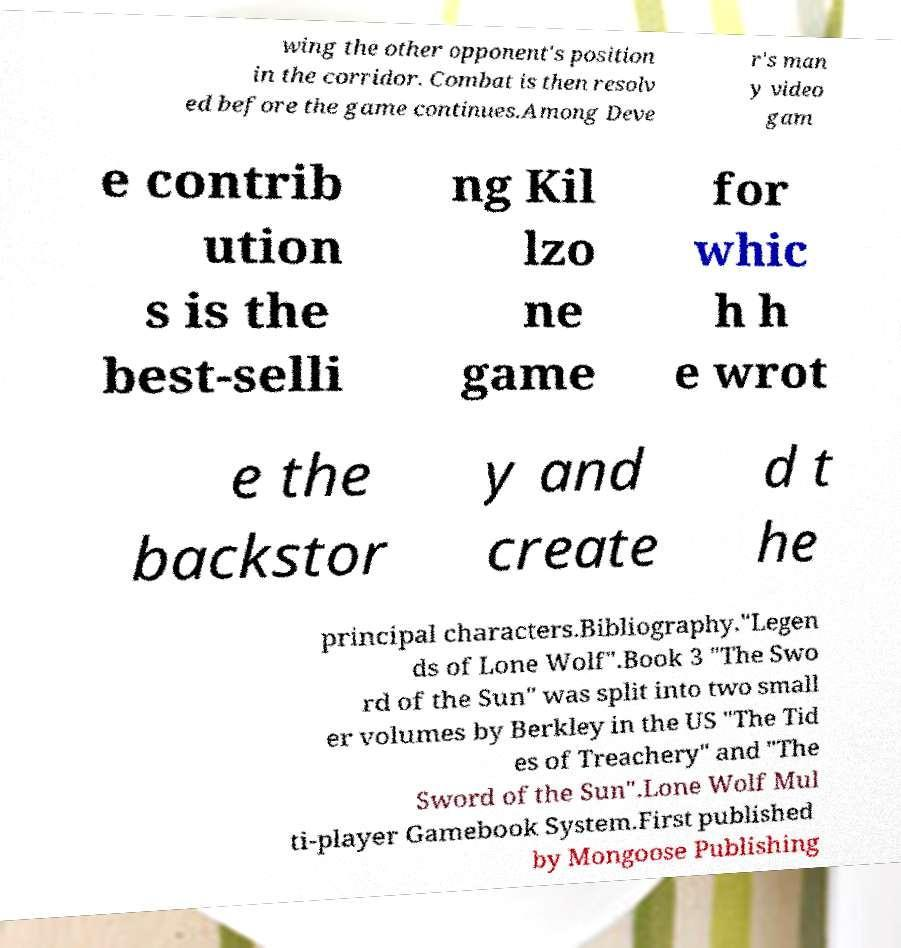Could you assist in decoding the text presented in this image and type it out clearly? wing the other opponent's position in the corridor. Combat is then resolv ed before the game continues.Among Deve r's man y video gam e contrib ution s is the best-selli ng Kil lzo ne game for whic h h e wrot e the backstor y and create d t he principal characters.Bibliography."Legen ds of Lone Wolf".Book 3 "The Swo rd of the Sun" was split into two small er volumes by Berkley in the US "The Tid es of Treachery" and "The Sword of the Sun".Lone Wolf Mul ti-player Gamebook System.First published by Mongoose Publishing 